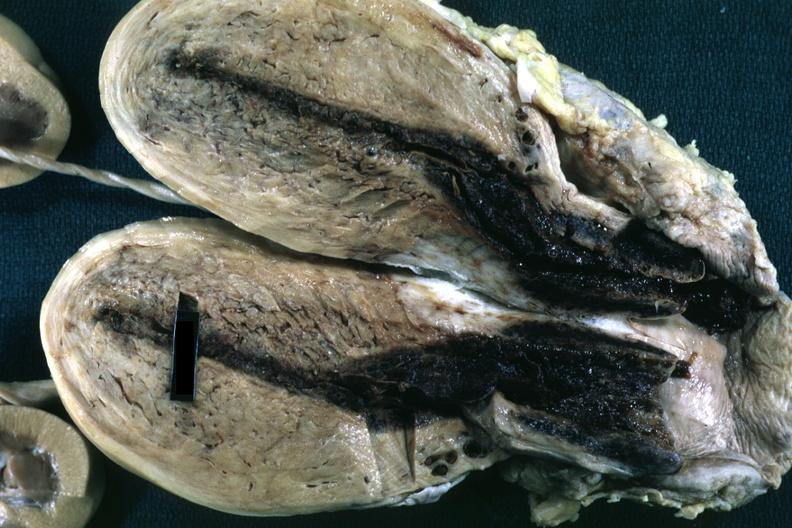s postpartum uterus present?
Answer the question using a single word or phrase. Yes 